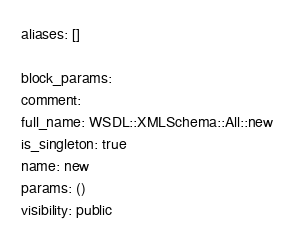Convert code to text. <code><loc_0><loc_0><loc_500><loc_500><_YAML_>aliases: []

block_params: 
comment: 
full_name: WSDL::XMLSchema::All::new
is_singleton: true
name: new
params: ()
visibility: public
</code> 